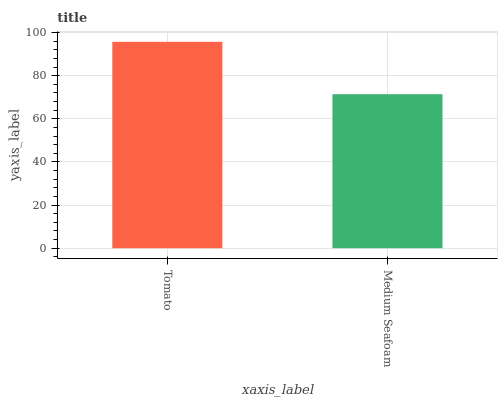Is Medium Seafoam the minimum?
Answer yes or no. Yes. Is Tomato the maximum?
Answer yes or no. Yes. Is Medium Seafoam the maximum?
Answer yes or no. No. Is Tomato greater than Medium Seafoam?
Answer yes or no. Yes. Is Medium Seafoam less than Tomato?
Answer yes or no. Yes. Is Medium Seafoam greater than Tomato?
Answer yes or no. No. Is Tomato less than Medium Seafoam?
Answer yes or no. No. Is Tomato the high median?
Answer yes or no. Yes. Is Medium Seafoam the low median?
Answer yes or no. Yes. Is Medium Seafoam the high median?
Answer yes or no. No. Is Tomato the low median?
Answer yes or no. No. 